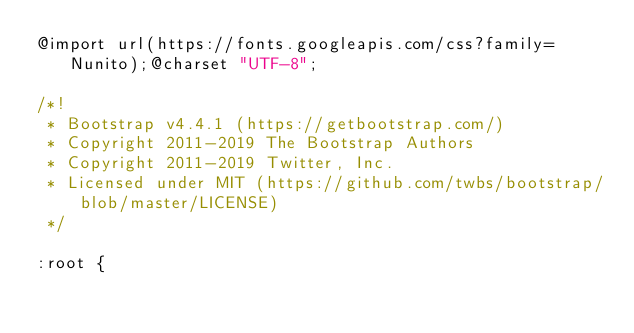Convert code to text. <code><loc_0><loc_0><loc_500><loc_500><_CSS_>@import url(https://fonts.googleapis.com/css?family=Nunito);@charset "UTF-8";

/*!
 * Bootstrap v4.4.1 (https://getbootstrap.com/)
 * Copyright 2011-2019 The Bootstrap Authors
 * Copyright 2011-2019 Twitter, Inc.
 * Licensed under MIT (https://github.com/twbs/bootstrap/blob/master/LICENSE)
 */

:root {</code> 